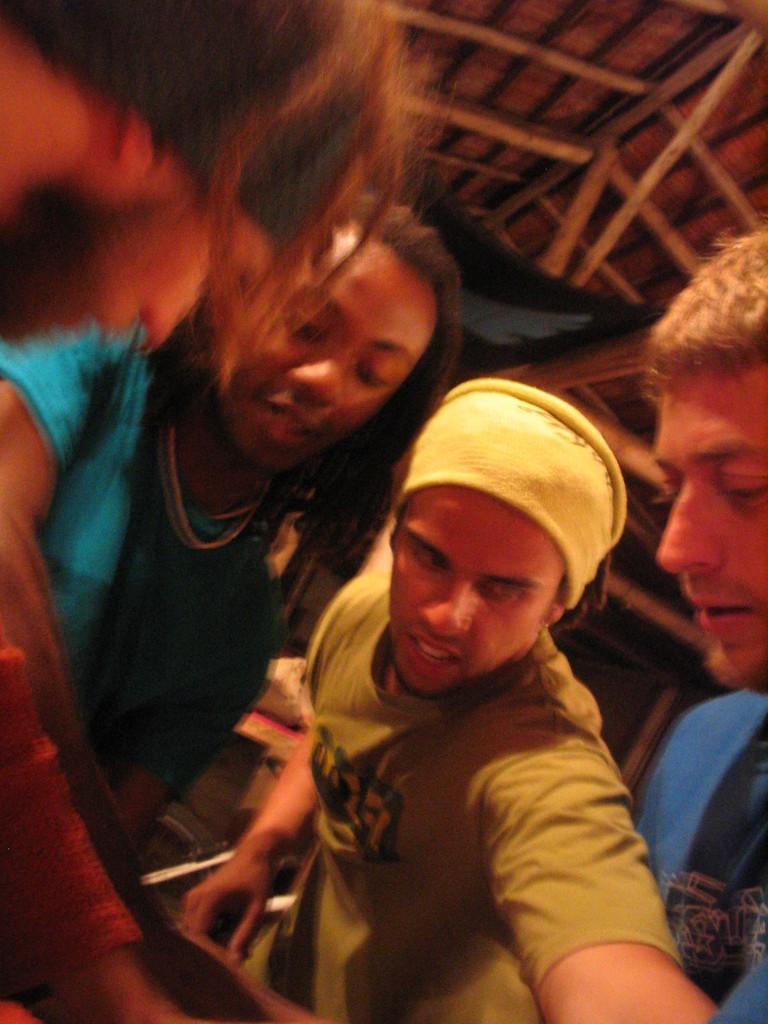Can you describe this image briefly? In this picture we can observe four members. All of them are men. One of them is wearing a cap on his head. In the background we can observe a wooden ceiling. 